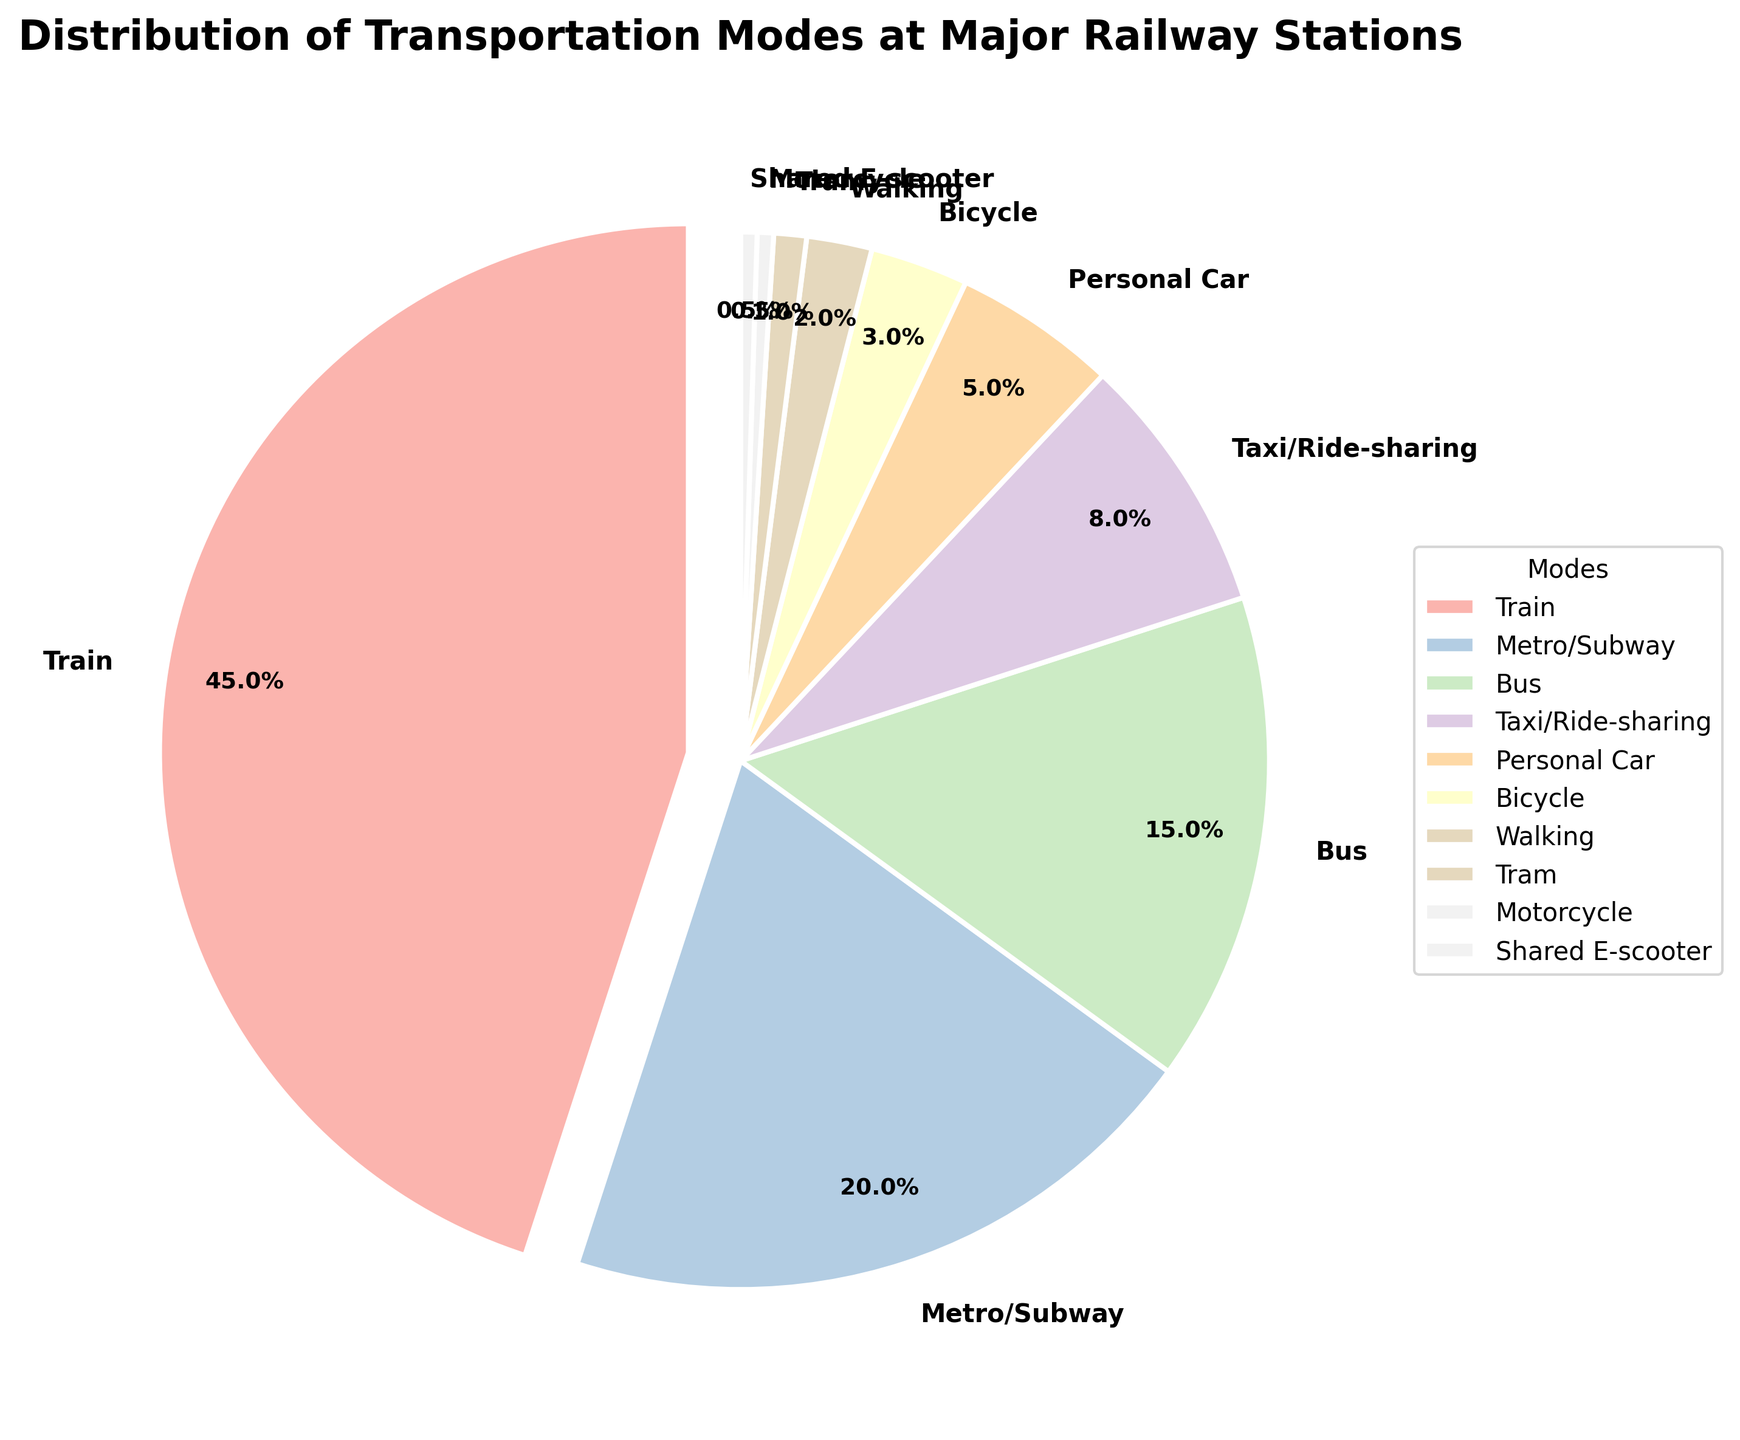What is the most common mode of transportation used by travelers at major railway stations? The pie chart shows the distribution of various transportation modes. The largest slice represents the most common mode. Here, the largest slice is for "Train" at 45%.
Answer: Train Which mode of transportation is used more, Metro/Subway or Bus? To determine which mode is used more, compare their percentages on the pie chart. "Metro/Subway" has a larger slice at 20% compared to "Bus" at 15%.
Answer: Metro/Subway What is the combined percentage of travelers using Taxi/Ride-sharing and Personal Car? Add the percentages of the two modes: Taxi/Ride-sharing (8%) and Personal Car (5%). 8% + 5% = 13%.
Answer: 13% How does the use of Bicycle compare to Walking? Compare the percentages of the two modes; Bicycle is at 3% while Walking is at 2%. This shows that Bicycle is used more than Walking.
Answer: Bicycle is used more What is the percentage difference between the most and least common transportation modes? The most common mode is Train at 45%, and the least common modes are Motorcycle and Shared E-scooter, each at 0.5%. The difference is 45% - 0.5% = 44.5%.
Answer: 44.5% How many modes of transportation are used by less than 5% of travelers? Identify the slices in the pie chart with percentages less than 5%. These modes are Personal Car (5%), Bicycle (3%), Walking (2%), Tram (1%), Motorcycle (0.5%), and Shared E-scooter (0.5%). Count them: 6 modes.
Answer: 6 modes If the percentage of travelers using the Train mode increased by 5%, what would it be? Increase the current percentage of Train by 5%. The current percentage is 45%, so 45% + 5% = 50%.
Answer: 50% What is the total percentage of travelers using either Tram or Motorcycle? Add the percentages of Tram (1%) and Motorcycle (0.5%). 1% + 0.5% = 1.5%.
Answer: 1.5% Arrange the modes of transportation from most to least used based on the pie chart. List the modes in descending order of their percentages: Train (45%), Metro/Subway (20%), Bus (15%), Taxi/Ride-sharing (8%), Personal Car (5%), Bicycle (3%), Walking (2%), Tram (1%), Motorcycle (0.5%), Shared E-scooter (0.5%).
Answer: Train, Metro/Subway, Bus, Taxi/Ride-sharing, Personal Car, Bicycle, Walking, Tram, Motorcycle, Shared E-scooter 